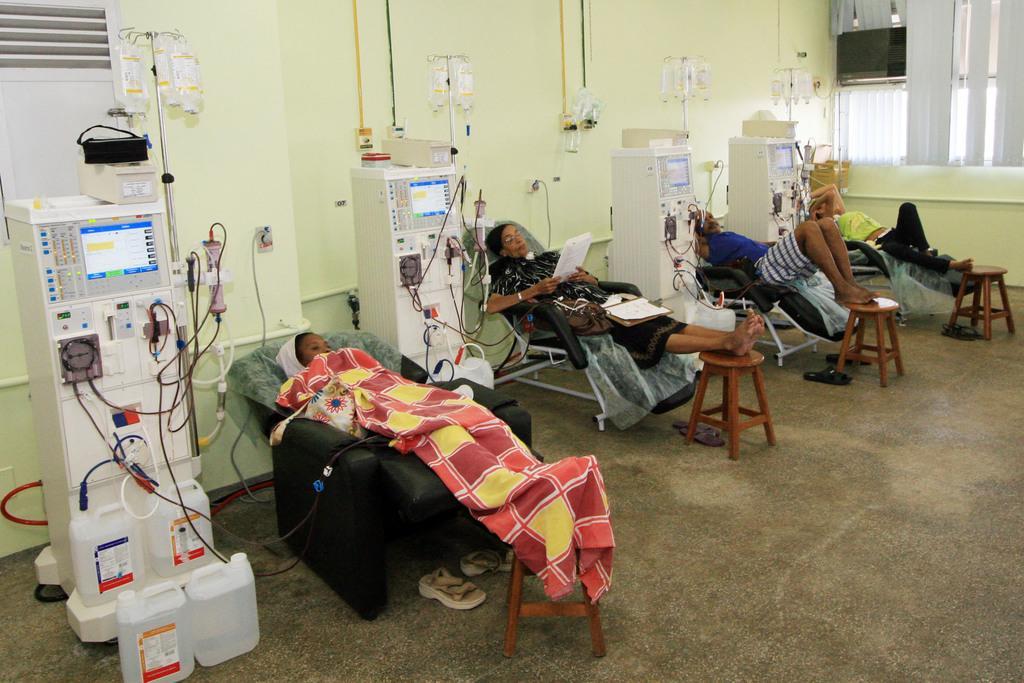Could you give a brief overview of what you see in this image? In this image there are people lying on the chairs. In front of them there are stools. Beside them there are saline bottles, machines and cans. Behind them there is a wall. To the right there are window blinds to the wall. There is a television hanging. 